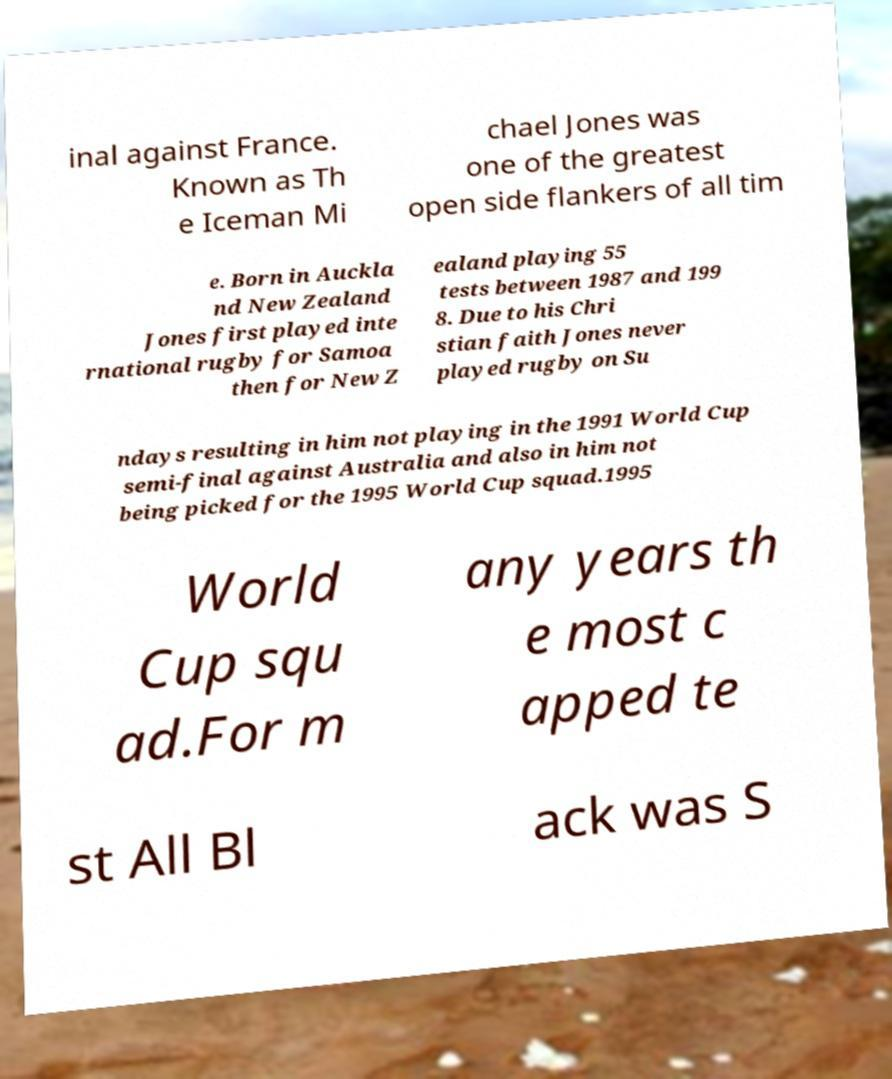Can you accurately transcribe the text from the provided image for me? inal against France. Known as Th e Iceman Mi chael Jones was one of the greatest open side flankers of all tim e. Born in Auckla nd New Zealand Jones first played inte rnational rugby for Samoa then for New Z ealand playing 55 tests between 1987 and 199 8. Due to his Chri stian faith Jones never played rugby on Su ndays resulting in him not playing in the 1991 World Cup semi-final against Australia and also in him not being picked for the 1995 World Cup squad.1995 World Cup squ ad.For m any years th e most c apped te st All Bl ack was S 